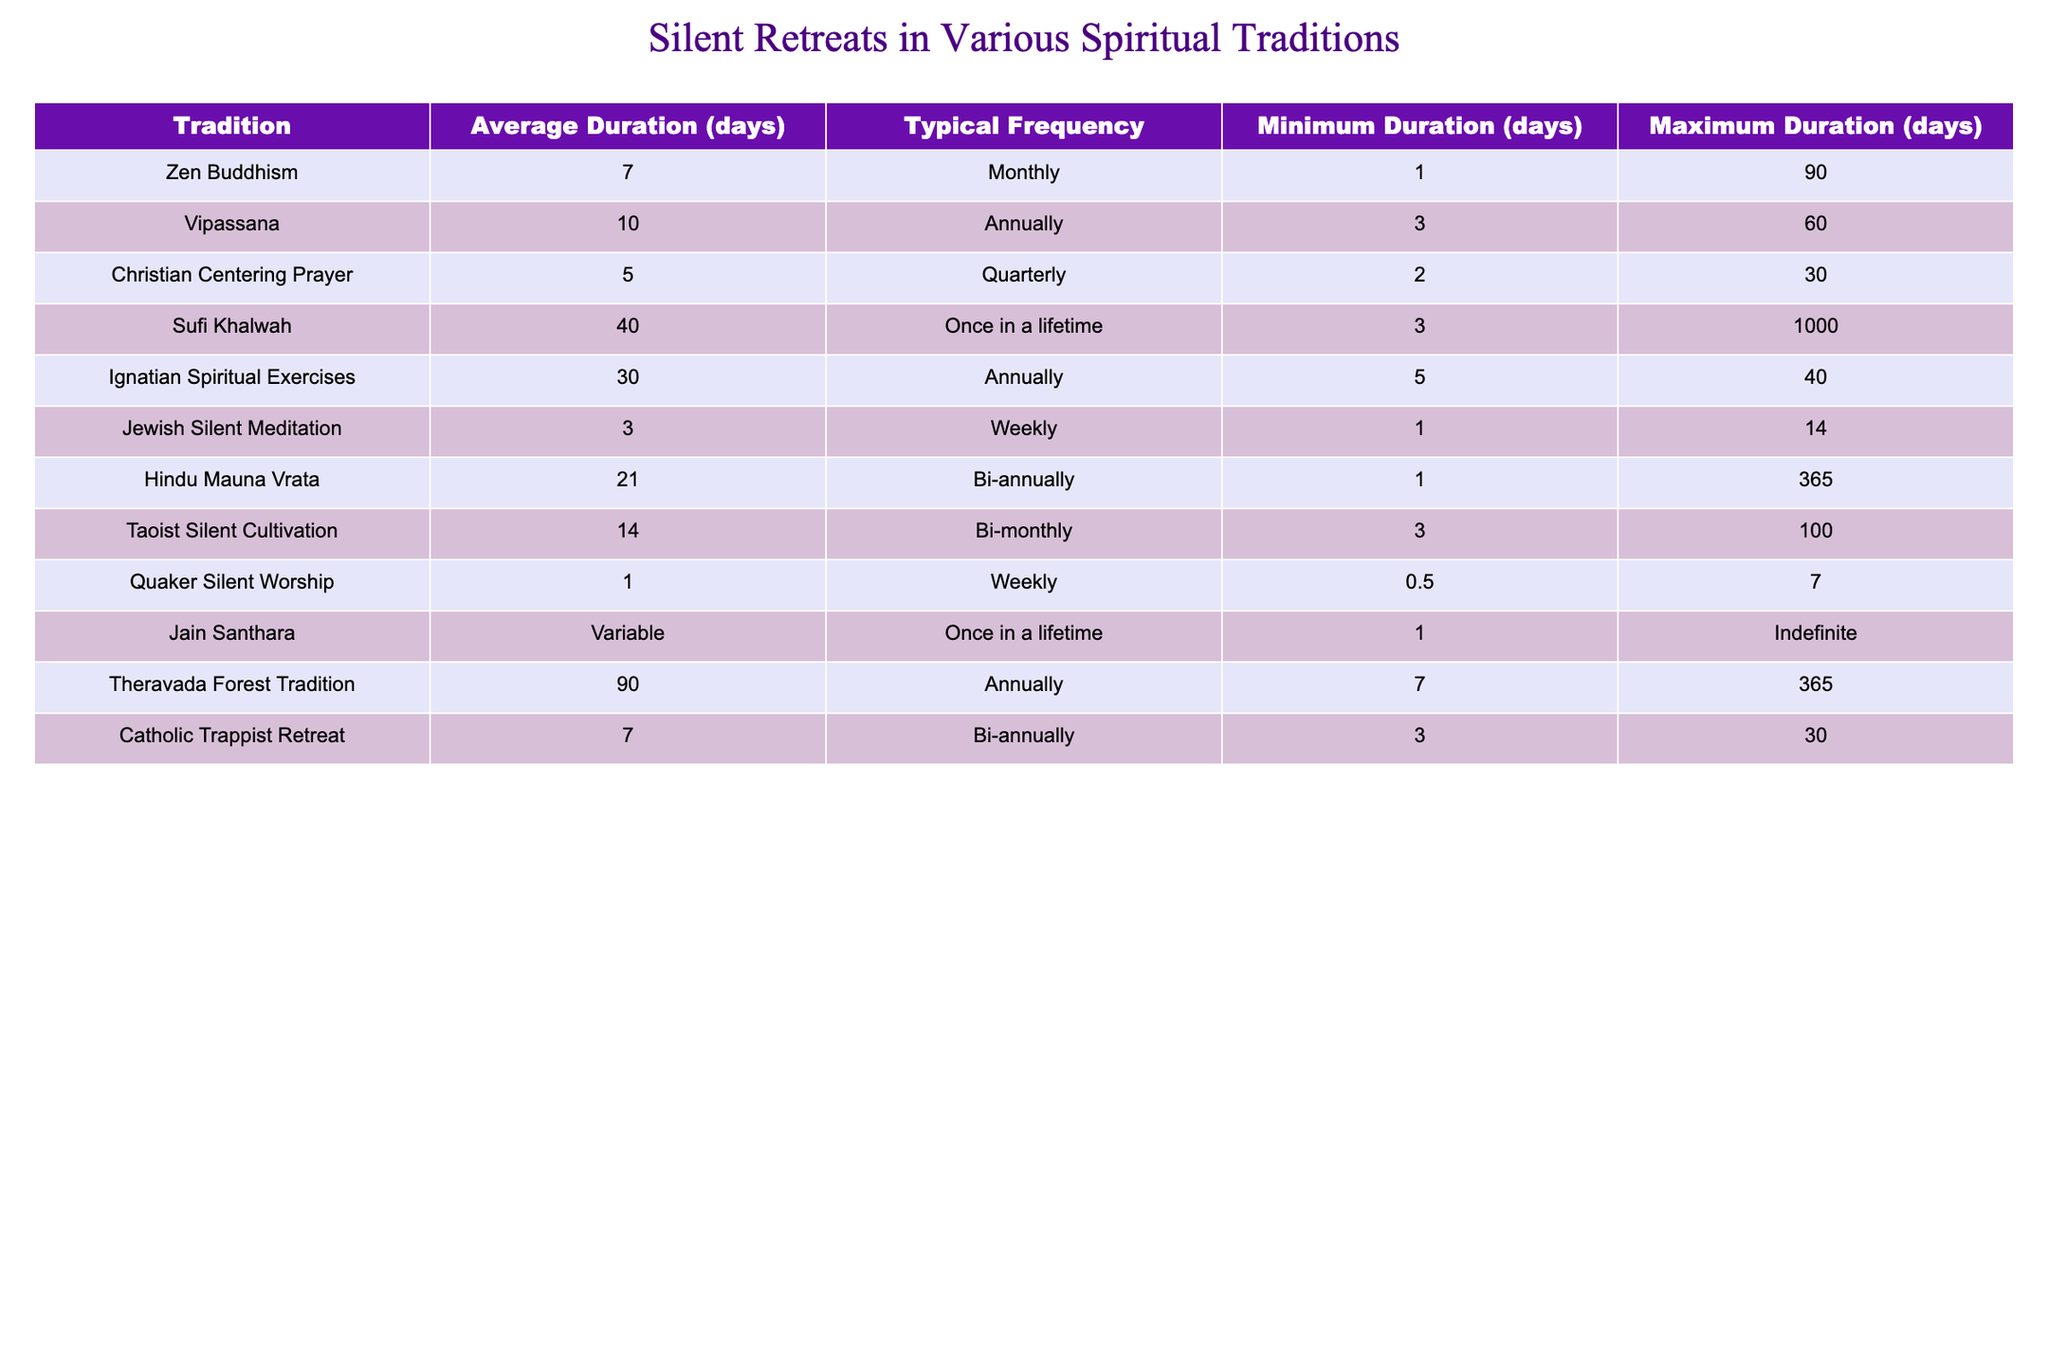What is the average duration of silent retreats in Vipassana? The table shows that the average duration of silent retreats in Vipassana is 10 days.
Answer: 10 days How many days is the maximum duration for Sufi Khalwah retreats? Referring to the table, the maximum duration for Sufi Khalwah retreats is 1000 days.
Answer: 1000 days Is the Jewish Silent Meditation conducted weekly? Yes, the table indicates that Jewish Silent Meditation is typically held on a weekly basis.
Answer: Yes What is the minimum duration for a retreat in Christian Centering Prayer? According to the table, the minimum duration for Christian Centering Prayer retreats is 2 days.
Answer: 2 days What is the typical frequency of retreats for Hindu Mauna Vrata? The table states that Hindu Mauna Vrata retreats have a bi-annual frequency.
Answer: Bi-annually What is the range of days for the duration of Jain Santhara retreats? The table specifies that the duration for Jain Santhara is variable and can be indefinite.
Answer: Variable, indefinite What is the average duration of silent retreats across all traditions mentioned in the table? By calculating, the total average duration is (7 + 10 + 5 + 40 + 30 + 3 + 21 + 14 + 1 + 21 + 90 + 7) = 238 days across 12 traditions, resulting in an average of 238/12 ≈ 19.83 days.
Answer: Approximately 19.83 days Which tradition has the longest average retreat duration? The longest average duration is found in the Theravada Forest Tradition, which is 90 days.
Answer: Theravada Forest Tradition How often are Quaker Silent Worship retreats held? The table indicates that Quaker Silent Worship is held weekly.
Answer: Weekly What is the difference between the average duration of Zen Buddhism and Ignatian Spiritual Exercises? The average duration for Zen Buddhism is 7 days and for Ignatian Spiritual Exercises is 30 days, so the difference is 30 - 7 = 23 days.
Answer: 23 days Which tradition has the lowest typical frequency, and what is it? The lowest typical frequency is for Sufi Khalwah, which is described as "Once in a lifetime."
Answer: Once in a lifetime 